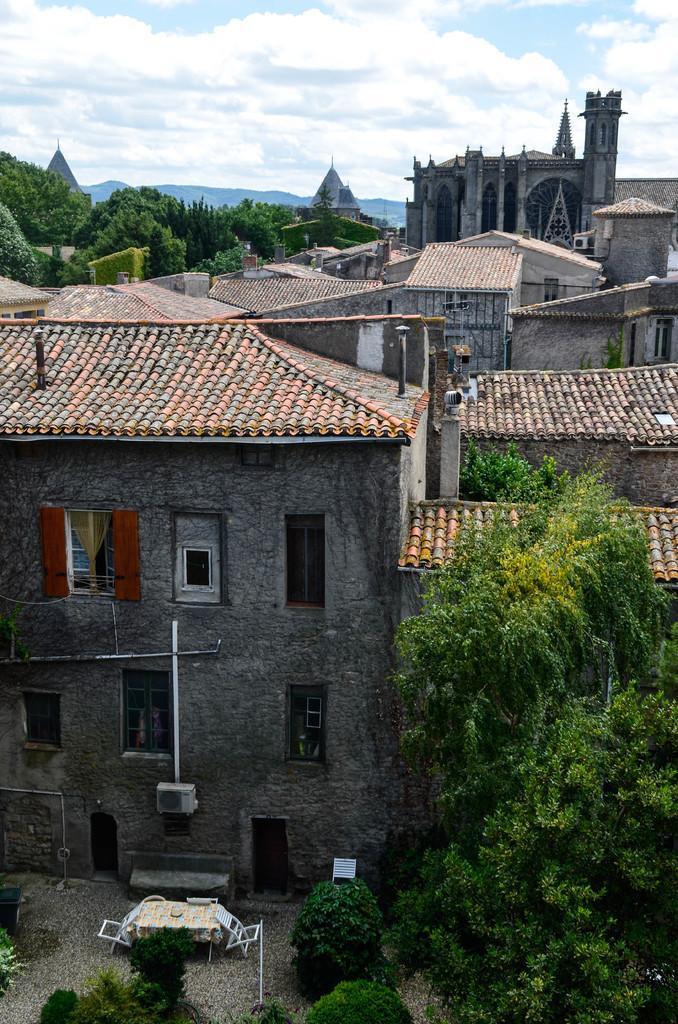Can you describe this image briefly? In this picture we can observe some buildings. There are trees. In the background there are hills and a sky with clouds. 